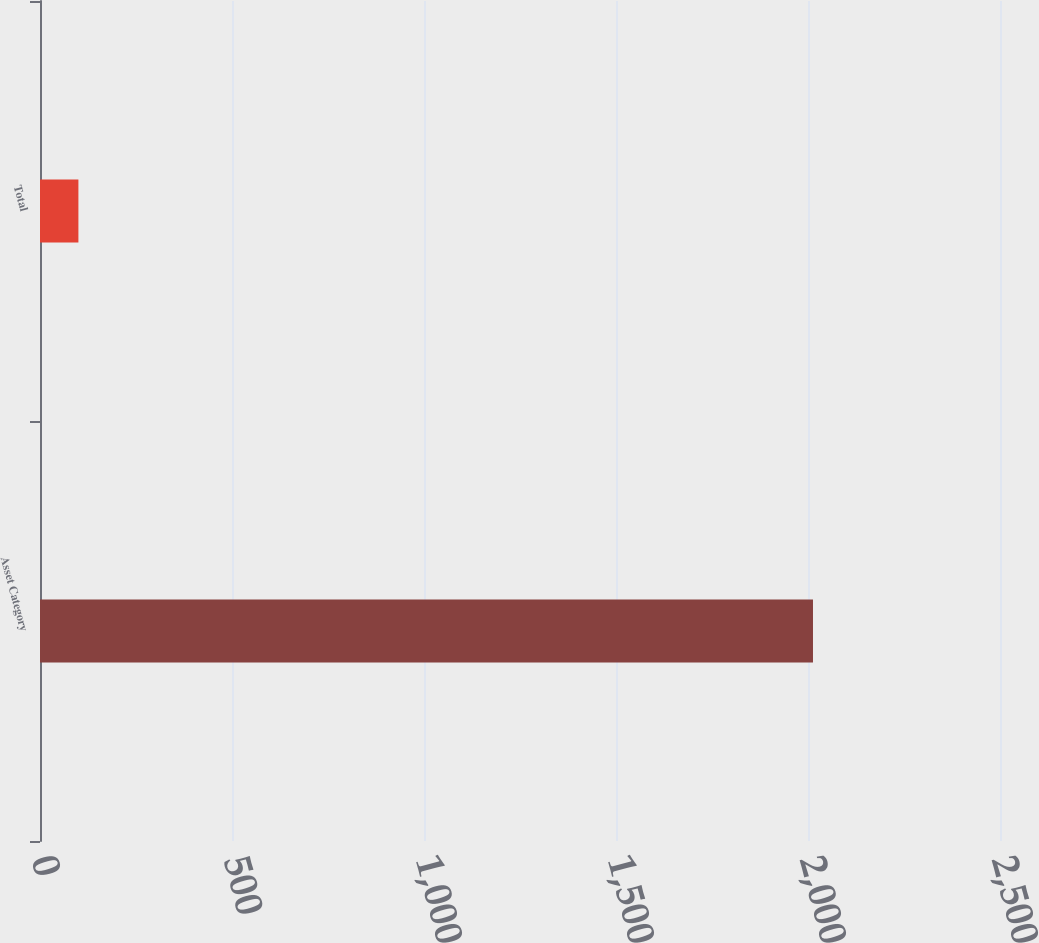Convert chart. <chart><loc_0><loc_0><loc_500><loc_500><bar_chart><fcel>Asset Category<fcel>Total<nl><fcel>2013<fcel>100<nl></chart> 